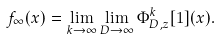Convert formula to latex. <formula><loc_0><loc_0><loc_500><loc_500>f _ { \infty } ( x ) = \lim _ { k \rightarrow \infty } \lim _ { D \rightarrow \infty } \Phi _ { D , z } ^ { k } [ 1 ] ( x ) .</formula> 